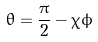Convert formula to latex. <formula><loc_0><loc_0><loc_500><loc_500>\theta = \frac { \pi } { 2 } - \chi \phi</formula> 